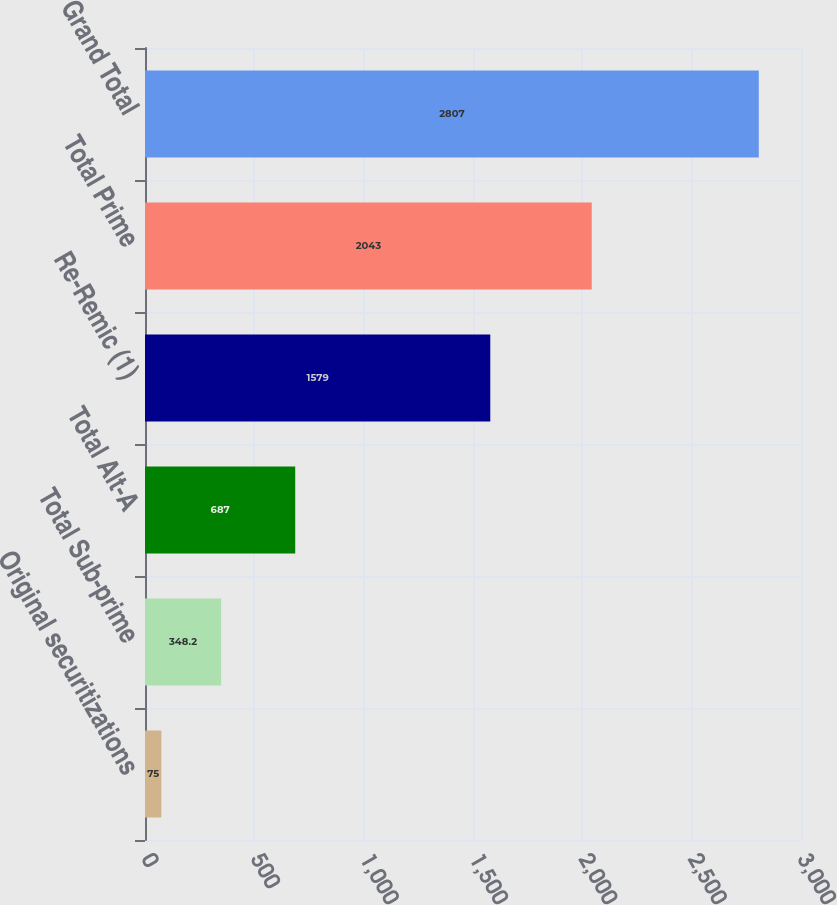Convert chart to OTSL. <chart><loc_0><loc_0><loc_500><loc_500><bar_chart><fcel>Original securitizations<fcel>Total Sub-prime<fcel>Total Alt-A<fcel>Re-Remic (1)<fcel>Total Prime<fcel>Grand Total<nl><fcel>75<fcel>348.2<fcel>687<fcel>1579<fcel>2043<fcel>2807<nl></chart> 